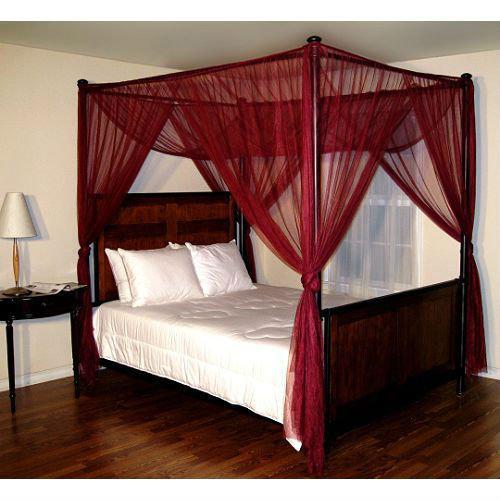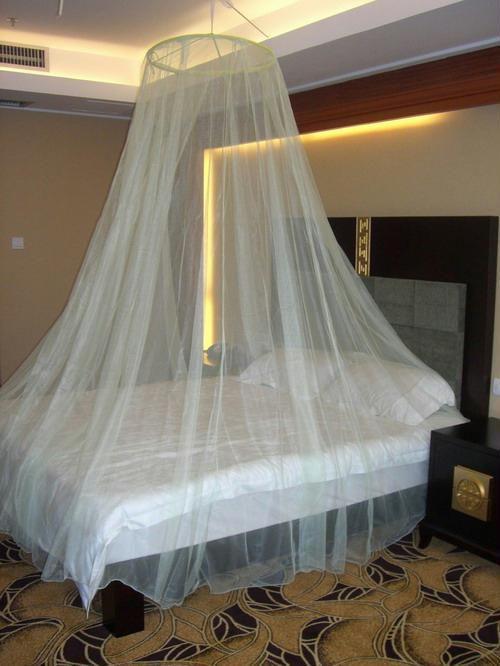The first image is the image on the left, the second image is the image on the right. Assess this claim about the two images: "There is a bed with canopy netting tied at each of four corners.". Correct or not? Answer yes or no. Yes. 